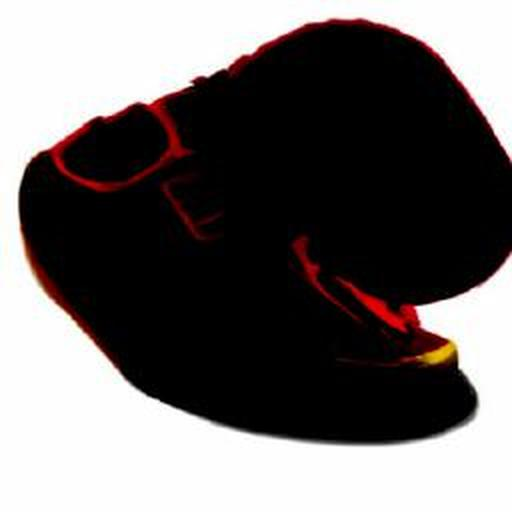What might this dark object be? While the image is quite obscure, the dark shape could resemble a helmet or a headgear of some sort, with faint red highlights indicating some form of design or emblem. 